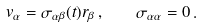Convert formula to latex. <formula><loc_0><loc_0><loc_500><loc_500>v _ { \alpha } = \sigma _ { \alpha \beta } ( t ) r _ { \beta } \, , \quad \sigma _ { \alpha \alpha } = 0 \, .</formula> 